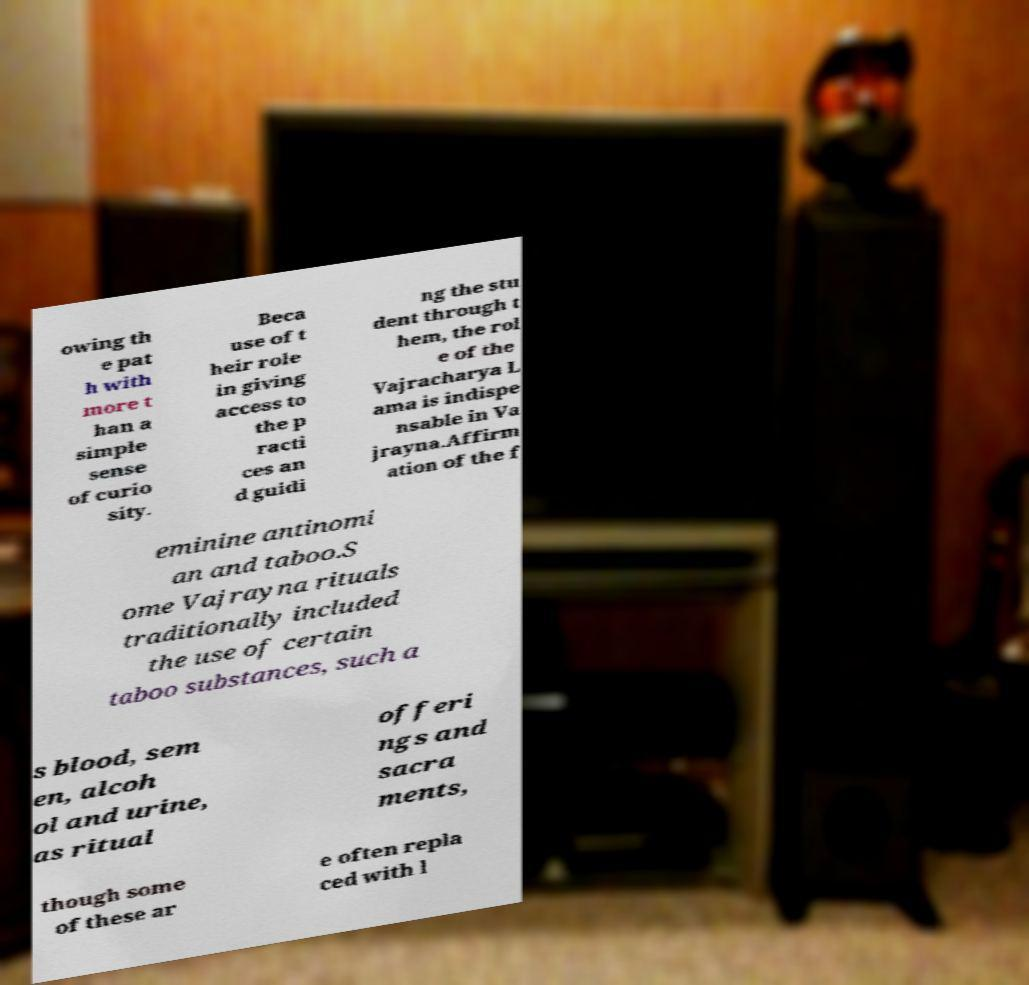Please read and relay the text visible in this image. What does it say? owing th e pat h with more t han a simple sense of curio sity. Beca use of t heir role in giving access to the p racti ces an d guidi ng the stu dent through t hem, the rol e of the Vajracharya L ama is indispe nsable in Va jrayna.Affirm ation of the f eminine antinomi an and taboo.S ome Vajrayna rituals traditionally included the use of certain taboo substances, such a s blood, sem en, alcoh ol and urine, as ritual offeri ngs and sacra ments, though some of these ar e often repla ced with l 